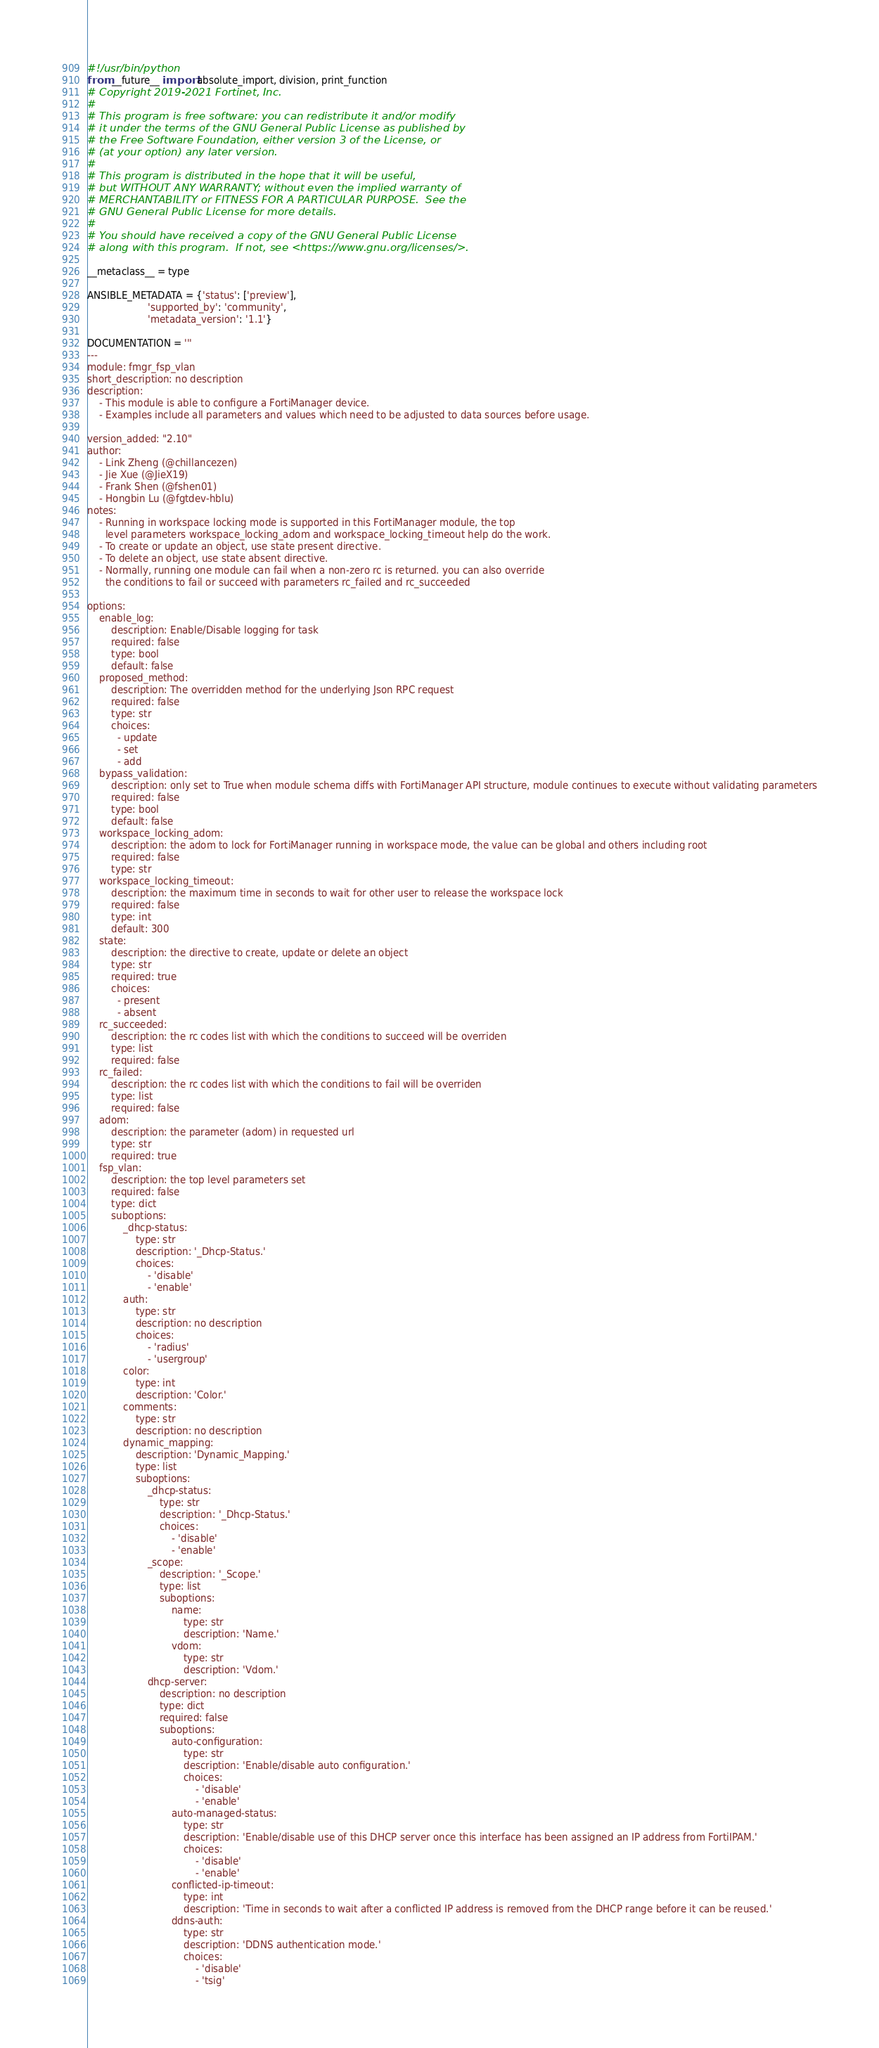<code> <loc_0><loc_0><loc_500><loc_500><_Python_>#!/usr/bin/python
from __future__ import absolute_import, division, print_function
# Copyright 2019-2021 Fortinet, Inc.
#
# This program is free software: you can redistribute it and/or modify
# it under the terms of the GNU General Public License as published by
# the Free Software Foundation, either version 3 of the License, or
# (at your option) any later version.
#
# This program is distributed in the hope that it will be useful,
# but WITHOUT ANY WARRANTY; without even the implied warranty of
# MERCHANTABILITY or FITNESS FOR A PARTICULAR PURPOSE.  See the
# GNU General Public License for more details.
#
# You should have received a copy of the GNU General Public License
# along with this program.  If not, see <https://www.gnu.org/licenses/>.

__metaclass__ = type

ANSIBLE_METADATA = {'status': ['preview'],
                    'supported_by': 'community',
                    'metadata_version': '1.1'}

DOCUMENTATION = '''
---
module: fmgr_fsp_vlan
short_description: no description
description:
    - This module is able to configure a FortiManager device.
    - Examples include all parameters and values which need to be adjusted to data sources before usage.

version_added: "2.10"
author:
    - Link Zheng (@chillancezen)
    - Jie Xue (@JieX19)
    - Frank Shen (@fshen01)
    - Hongbin Lu (@fgtdev-hblu)
notes:
    - Running in workspace locking mode is supported in this FortiManager module, the top
      level parameters workspace_locking_adom and workspace_locking_timeout help do the work.
    - To create or update an object, use state present directive.
    - To delete an object, use state absent directive.
    - Normally, running one module can fail when a non-zero rc is returned. you can also override
      the conditions to fail or succeed with parameters rc_failed and rc_succeeded

options:
    enable_log:
        description: Enable/Disable logging for task
        required: false
        type: bool
        default: false
    proposed_method:
        description: The overridden method for the underlying Json RPC request
        required: false
        type: str
        choices:
          - update
          - set
          - add
    bypass_validation:
        description: only set to True when module schema diffs with FortiManager API structure, module continues to execute without validating parameters
        required: false
        type: bool
        default: false
    workspace_locking_adom:
        description: the adom to lock for FortiManager running in workspace mode, the value can be global and others including root
        required: false
        type: str
    workspace_locking_timeout:
        description: the maximum time in seconds to wait for other user to release the workspace lock
        required: false
        type: int
        default: 300
    state:
        description: the directive to create, update or delete an object
        type: str
        required: true
        choices:
          - present
          - absent
    rc_succeeded:
        description: the rc codes list with which the conditions to succeed will be overriden
        type: list
        required: false
    rc_failed:
        description: the rc codes list with which the conditions to fail will be overriden
        type: list
        required: false
    adom:
        description: the parameter (adom) in requested url
        type: str
        required: true
    fsp_vlan:
        description: the top level parameters set
        required: false
        type: dict
        suboptions:
            _dhcp-status:
                type: str
                description: '_Dhcp-Status.'
                choices:
                    - 'disable'
                    - 'enable'
            auth:
                type: str
                description: no description
                choices:
                    - 'radius'
                    - 'usergroup'
            color:
                type: int
                description: 'Color.'
            comments:
                type: str
                description: no description
            dynamic_mapping:
                description: 'Dynamic_Mapping.'
                type: list
                suboptions:
                    _dhcp-status:
                        type: str
                        description: '_Dhcp-Status.'
                        choices:
                            - 'disable'
                            - 'enable'
                    _scope:
                        description: '_Scope.'
                        type: list
                        suboptions:
                            name:
                                type: str
                                description: 'Name.'
                            vdom:
                                type: str
                                description: 'Vdom.'
                    dhcp-server:
                        description: no description
                        type: dict
                        required: false
                        suboptions:
                            auto-configuration:
                                type: str
                                description: 'Enable/disable auto configuration.'
                                choices:
                                    - 'disable'
                                    - 'enable'
                            auto-managed-status:
                                type: str
                                description: 'Enable/disable use of this DHCP server once this interface has been assigned an IP address from FortiIPAM.'
                                choices:
                                    - 'disable'
                                    - 'enable'
                            conflicted-ip-timeout:
                                type: int
                                description: 'Time in seconds to wait after a conflicted IP address is removed from the DHCP range before it can be reused.'
                            ddns-auth:
                                type: str
                                description: 'DDNS authentication mode.'
                                choices:
                                    - 'disable'
                                    - 'tsig'</code> 